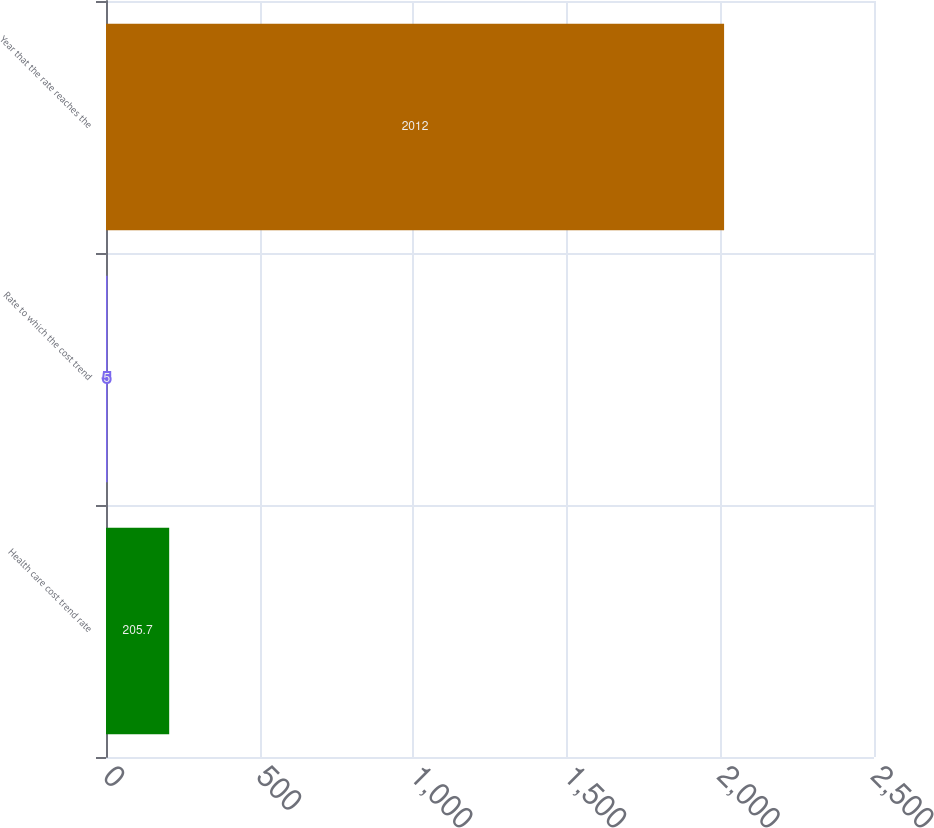Convert chart to OTSL. <chart><loc_0><loc_0><loc_500><loc_500><bar_chart><fcel>Health care cost trend rate<fcel>Rate to which the cost trend<fcel>Year that the rate reaches the<nl><fcel>205.7<fcel>5<fcel>2012<nl></chart> 